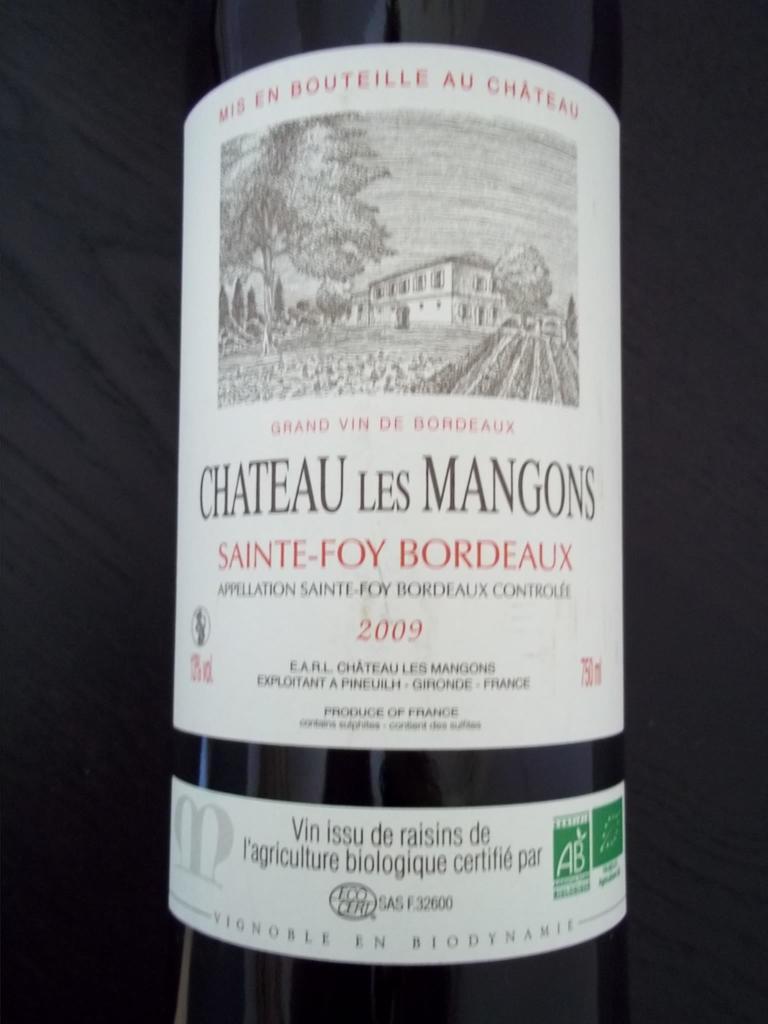What year was this wine made?
Make the answer very short. 2009. 